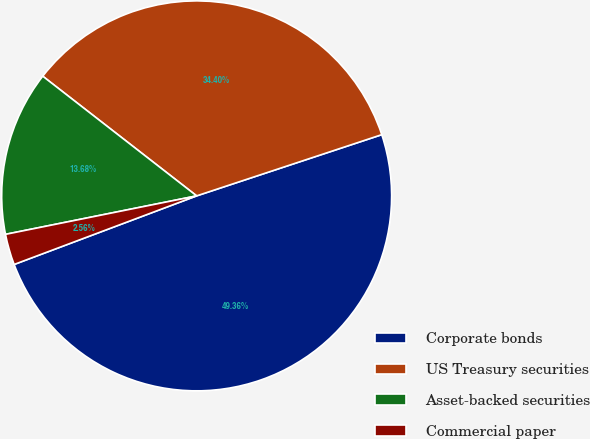Convert chart to OTSL. <chart><loc_0><loc_0><loc_500><loc_500><pie_chart><fcel>Corporate bonds<fcel>US Treasury securities<fcel>Asset-backed securities<fcel>Commercial paper<nl><fcel>49.36%<fcel>34.4%<fcel>13.68%<fcel>2.56%<nl></chart> 